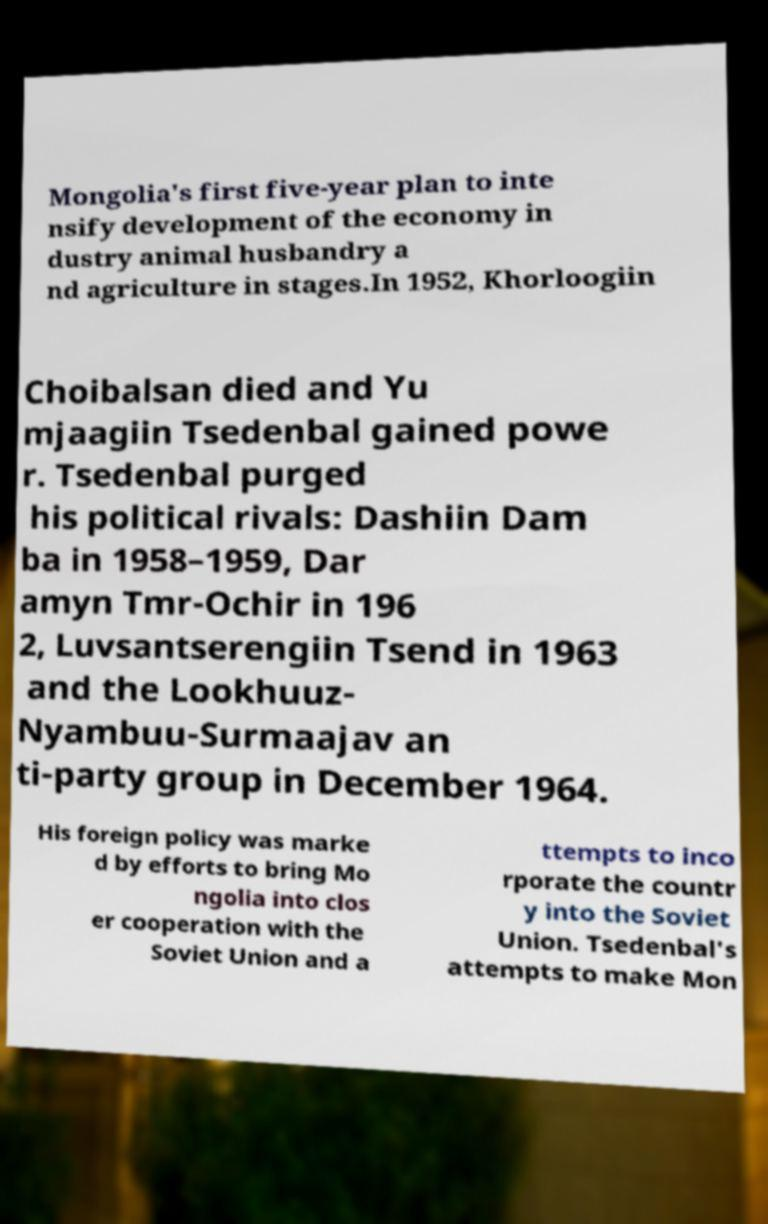I need the written content from this picture converted into text. Can you do that? Mongolia's first five-year plan to inte nsify development of the economy in dustry animal husbandry a nd agriculture in stages.In 1952, Khorloogiin Choibalsan died and Yu mjaagiin Tsedenbal gained powe r. Tsedenbal purged his political rivals: Dashiin Dam ba in 1958–1959, Dar amyn Tmr-Ochir in 196 2, Luvsantserengiin Tsend in 1963 and the Lookhuuz- Nyambuu-Surmaajav an ti-party group in December 1964. His foreign policy was marke d by efforts to bring Mo ngolia into clos er cooperation with the Soviet Union and a ttempts to inco rporate the countr y into the Soviet Union. Tsedenbal's attempts to make Mon 